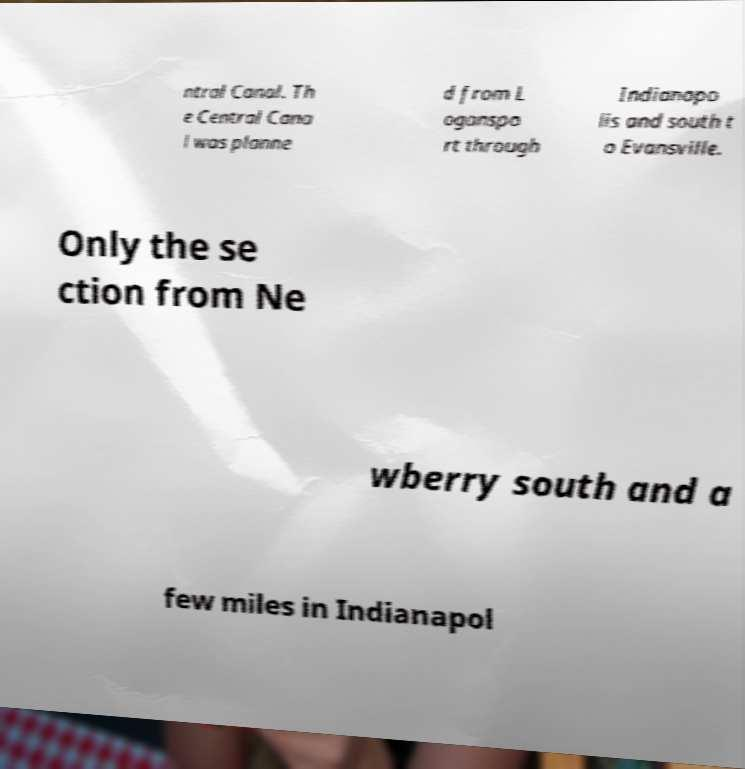Please identify and transcribe the text found in this image. ntral Canal. Th e Central Cana l was planne d from L oganspo rt through Indianapo lis and south t o Evansville. Only the se ction from Ne wberry south and a few miles in Indianapol 